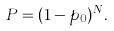<formula> <loc_0><loc_0><loc_500><loc_500>P = ( 1 - p _ { 0 } ) ^ { N } .</formula> 